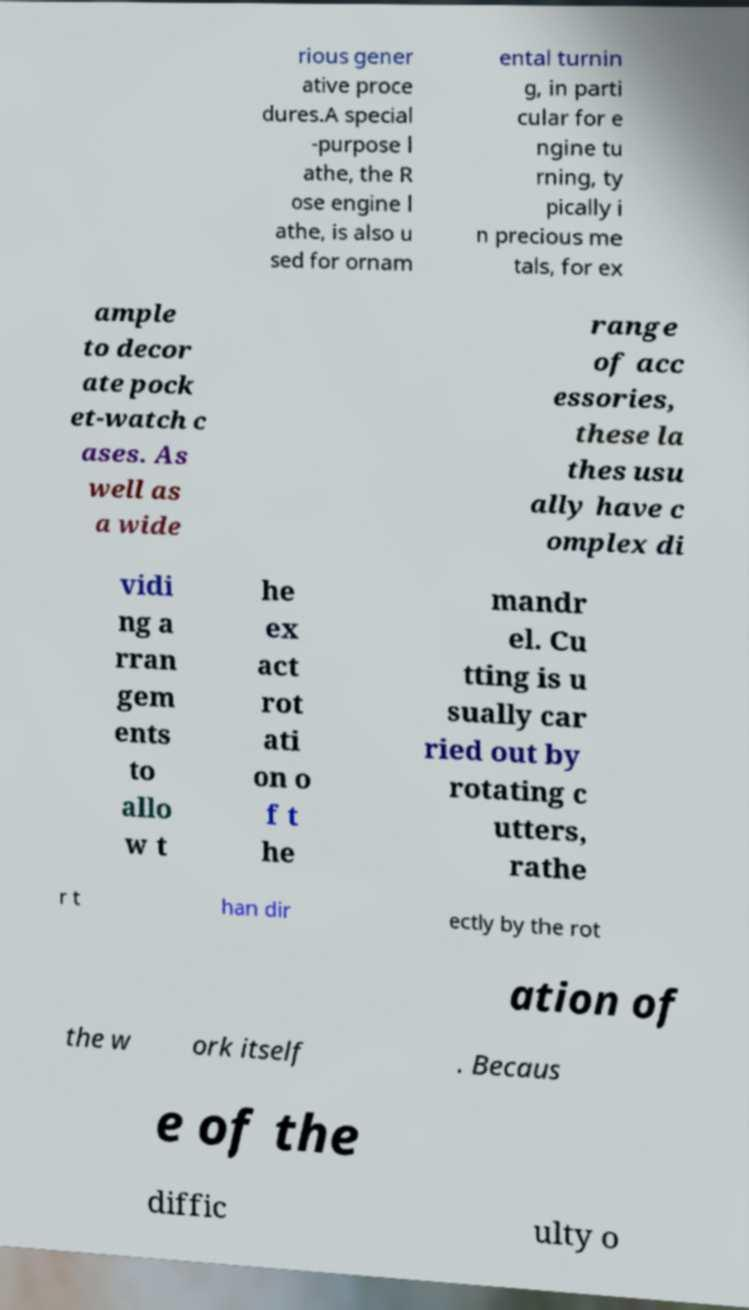Can you accurately transcribe the text from the provided image for me? rious gener ative proce dures.A special -purpose l athe, the R ose engine l athe, is also u sed for ornam ental turnin g, in parti cular for e ngine tu rning, ty pically i n precious me tals, for ex ample to decor ate pock et-watch c ases. As well as a wide range of acc essories, these la thes usu ally have c omplex di vidi ng a rran gem ents to allo w t he ex act rot ati on o f t he mandr el. Cu tting is u sually car ried out by rotating c utters, rathe r t han dir ectly by the rot ation of the w ork itself . Becaus e of the diffic ulty o 